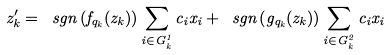Convert formula to latex. <formula><loc_0><loc_0><loc_500><loc_500>z _ { k } ^ { \prime } = \ s g n \left ( f _ { q _ { k } } ( z _ { k } ) \right ) \sum _ { i \in G _ { k } ^ { 1 } } c _ { i } x _ { i } + \ s g n \left ( g _ { q _ { k } } ( z _ { k } ) \right ) \sum _ { i \in G _ { k } ^ { 2 } } c _ { i } x _ { i }</formula> 